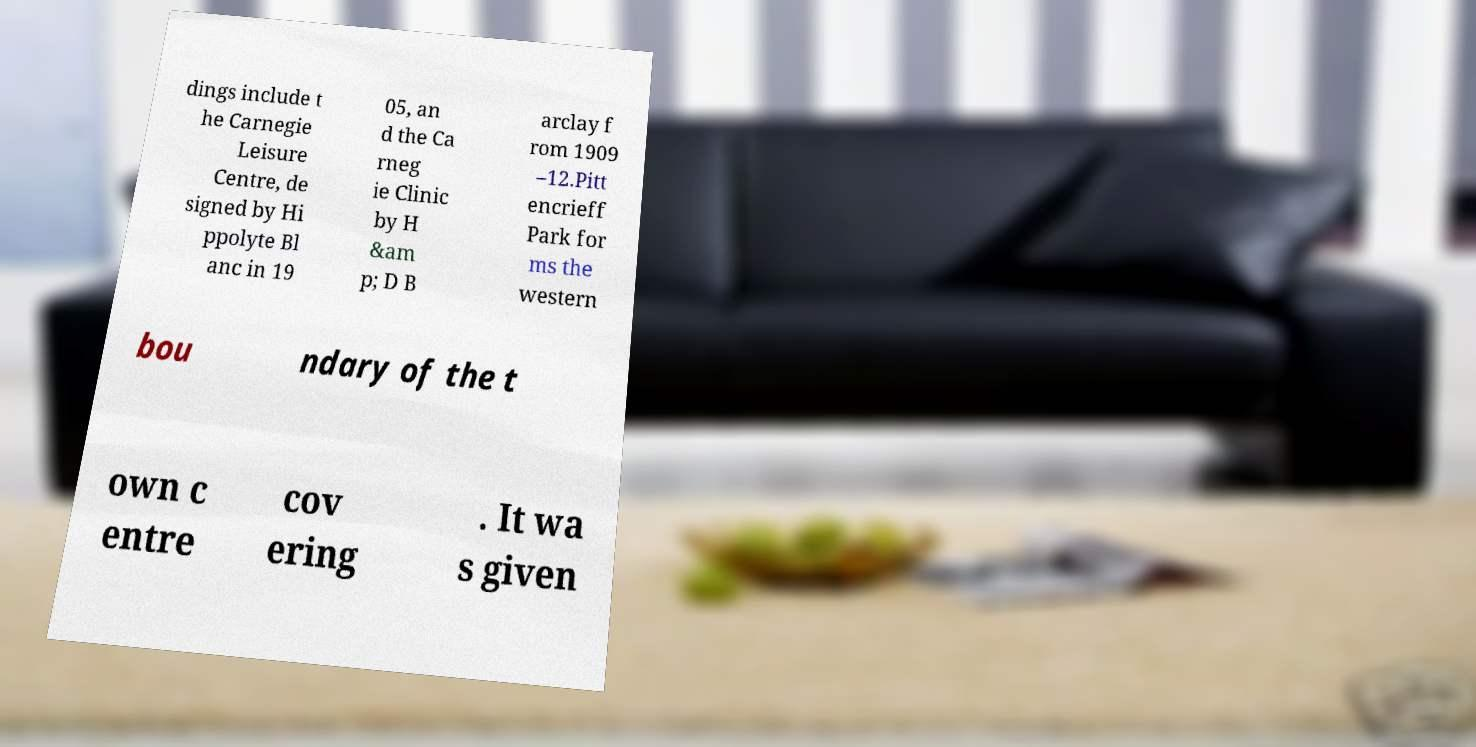For documentation purposes, I need the text within this image transcribed. Could you provide that? dings include t he Carnegie Leisure Centre, de signed by Hi ppolyte Bl anc in 19 05, an d the Ca rneg ie Clinic by H &am p; D B arclay f rom 1909 –12.Pitt encrieff Park for ms the western bou ndary of the t own c entre cov ering . It wa s given 